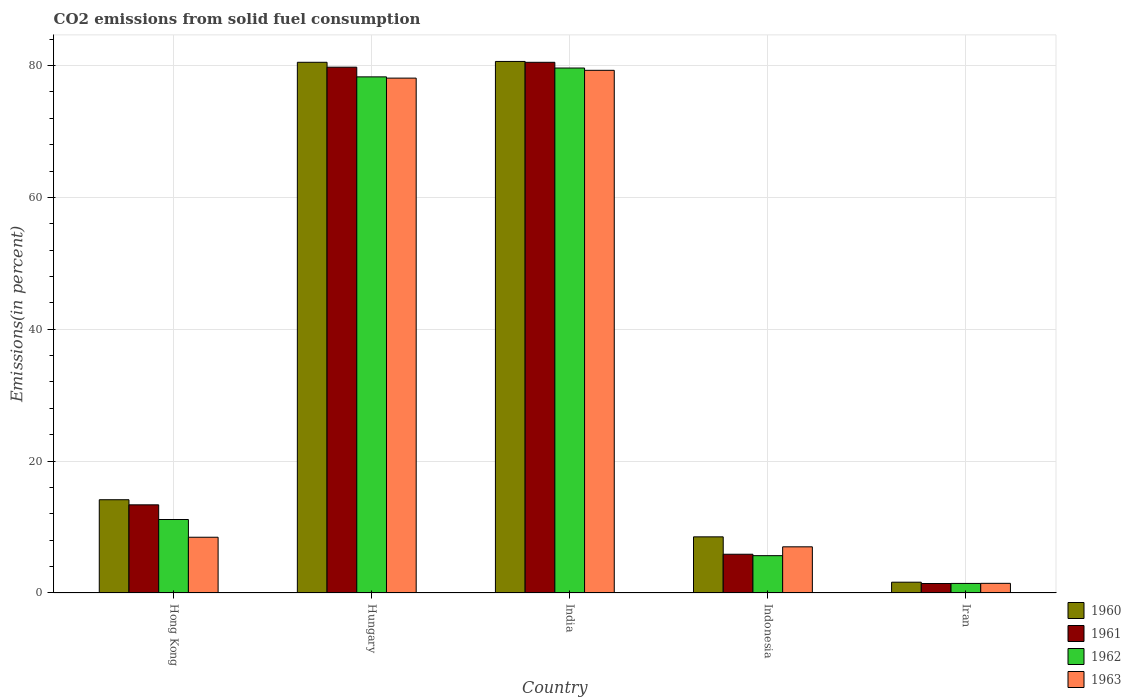How many different coloured bars are there?
Your answer should be very brief. 4. How many groups of bars are there?
Keep it short and to the point. 5. Are the number of bars per tick equal to the number of legend labels?
Offer a terse response. Yes. Are the number of bars on each tick of the X-axis equal?
Your response must be concise. Yes. How many bars are there on the 3rd tick from the left?
Keep it short and to the point. 4. How many bars are there on the 3rd tick from the right?
Provide a succinct answer. 4. What is the label of the 1st group of bars from the left?
Your response must be concise. Hong Kong. What is the total CO2 emitted in 1963 in Hong Kong?
Give a very brief answer. 8.46. Across all countries, what is the maximum total CO2 emitted in 1960?
Offer a very short reply. 80.62. Across all countries, what is the minimum total CO2 emitted in 1962?
Provide a succinct answer. 1.45. In which country was the total CO2 emitted in 1961 maximum?
Your answer should be compact. India. In which country was the total CO2 emitted in 1962 minimum?
Your answer should be very brief. Iran. What is the total total CO2 emitted in 1962 in the graph?
Keep it short and to the point. 176.15. What is the difference between the total CO2 emitted in 1961 in Hong Kong and that in India?
Offer a very short reply. -67.12. What is the difference between the total CO2 emitted in 1960 in Indonesia and the total CO2 emitted in 1963 in Hong Kong?
Offer a terse response. 0.06. What is the average total CO2 emitted in 1961 per country?
Offer a very short reply. 36.18. What is the difference between the total CO2 emitted of/in 1963 and total CO2 emitted of/in 1960 in Indonesia?
Your answer should be compact. -1.51. What is the ratio of the total CO2 emitted in 1960 in Hungary to that in India?
Give a very brief answer. 1. Is the total CO2 emitted in 1962 in Hong Kong less than that in Indonesia?
Your response must be concise. No. What is the difference between the highest and the second highest total CO2 emitted in 1963?
Make the answer very short. -69.63. What is the difference between the highest and the lowest total CO2 emitted in 1962?
Your answer should be very brief. 78.17. In how many countries, is the total CO2 emitted in 1963 greater than the average total CO2 emitted in 1963 taken over all countries?
Offer a terse response. 2. Is the sum of the total CO2 emitted in 1963 in Hungary and Iran greater than the maximum total CO2 emitted in 1961 across all countries?
Offer a terse response. No. Is it the case that in every country, the sum of the total CO2 emitted in 1960 and total CO2 emitted in 1962 is greater than the sum of total CO2 emitted in 1963 and total CO2 emitted in 1961?
Provide a succinct answer. No. What does the 2nd bar from the left in Indonesia represents?
Offer a very short reply. 1961. What does the 1st bar from the right in Iran represents?
Give a very brief answer. 1963. Are the values on the major ticks of Y-axis written in scientific E-notation?
Ensure brevity in your answer.  No. How many legend labels are there?
Offer a terse response. 4. How are the legend labels stacked?
Offer a terse response. Vertical. What is the title of the graph?
Your answer should be very brief. CO2 emissions from solid fuel consumption. Does "2009" appear as one of the legend labels in the graph?
Provide a succinct answer. No. What is the label or title of the Y-axis?
Offer a very short reply. Emissions(in percent). What is the Emissions(in percent) of 1960 in Hong Kong?
Give a very brief answer. 14.14. What is the Emissions(in percent) in 1961 in Hong Kong?
Offer a terse response. 13.37. What is the Emissions(in percent) of 1962 in Hong Kong?
Make the answer very short. 11.14. What is the Emissions(in percent) in 1963 in Hong Kong?
Your answer should be very brief. 8.46. What is the Emissions(in percent) of 1960 in Hungary?
Offer a terse response. 80.49. What is the Emissions(in percent) of 1961 in Hungary?
Ensure brevity in your answer.  79.75. What is the Emissions(in percent) of 1962 in Hungary?
Make the answer very short. 78.28. What is the Emissions(in percent) in 1963 in Hungary?
Give a very brief answer. 78.09. What is the Emissions(in percent) in 1960 in India?
Give a very brief answer. 80.62. What is the Emissions(in percent) of 1961 in India?
Give a very brief answer. 80.49. What is the Emissions(in percent) in 1962 in India?
Your answer should be compact. 79.62. What is the Emissions(in percent) of 1963 in India?
Offer a terse response. 79.27. What is the Emissions(in percent) in 1960 in Indonesia?
Your response must be concise. 8.51. What is the Emissions(in percent) in 1961 in Indonesia?
Your response must be concise. 5.88. What is the Emissions(in percent) in 1962 in Indonesia?
Provide a succinct answer. 5.66. What is the Emissions(in percent) of 1963 in Indonesia?
Your answer should be compact. 7. What is the Emissions(in percent) in 1960 in Iran?
Your answer should be very brief. 1.64. What is the Emissions(in percent) in 1961 in Iran?
Your response must be concise. 1.44. What is the Emissions(in percent) of 1962 in Iran?
Your response must be concise. 1.45. What is the Emissions(in percent) in 1963 in Iran?
Your answer should be very brief. 1.46. Across all countries, what is the maximum Emissions(in percent) in 1960?
Offer a very short reply. 80.62. Across all countries, what is the maximum Emissions(in percent) of 1961?
Provide a short and direct response. 80.49. Across all countries, what is the maximum Emissions(in percent) in 1962?
Your answer should be compact. 79.62. Across all countries, what is the maximum Emissions(in percent) of 1963?
Offer a terse response. 79.27. Across all countries, what is the minimum Emissions(in percent) in 1960?
Your answer should be very brief. 1.64. Across all countries, what is the minimum Emissions(in percent) in 1961?
Give a very brief answer. 1.44. Across all countries, what is the minimum Emissions(in percent) in 1962?
Make the answer very short. 1.45. Across all countries, what is the minimum Emissions(in percent) of 1963?
Give a very brief answer. 1.46. What is the total Emissions(in percent) in 1960 in the graph?
Your response must be concise. 185.4. What is the total Emissions(in percent) in 1961 in the graph?
Your response must be concise. 180.91. What is the total Emissions(in percent) of 1962 in the graph?
Your answer should be compact. 176.15. What is the total Emissions(in percent) in 1963 in the graph?
Offer a very short reply. 174.28. What is the difference between the Emissions(in percent) in 1960 in Hong Kong and that in Hungary?
Ensure brevity in your answer.  -66.35. What is the difference between the Emissions(in percent) of 1961 in Hong Kong and that in Hungary?
Your answer should be compact. -66.38. What is the difference between the Emissions(in percent) of 1962 in Hong Kong and that in Hungary?
Your response must be concise. -67.13. What is the difference between the Emissions(in percent) of 1963 in Hong Kong and that in Hungary?
Your response must be concise. -69.63. What is the difference between the Emissions(in percent) of 1960 in Hong Kong and that in India?
Ensure brevity in your answer.  -66.47. What is the difference between the Emissions(in percent) of 1961 in Hong Kong and that in India?
Your answer should be very brief. -67.12. What is the difference between the Emissions(in percent) of 1962 in Hong Kong and that in India?
Offer a very short reply. -68.47. What is the difference between the Emissions(in percent) in 1963 in Hong Kong and that in India?
Your answer should be compact. -70.82. What is the difference between the Emissions(in percent) in 1960 in Hong Kong and that in Indonesia?
Give a very brief answer. 5.63. What is the difference between the Emissions(in percent) of 1961 in Hong Kong and that in Indonesia?
Provide a short and direct response. 7.49. What is the difference between the Emissions(in percent) of 1962 in Hong Kong and that in Indonesia?
Provide a succinct answer. 5.48. What is the difference between the Emissions(in percent) in 1963 in Hong Kong and that in Indonesia?
Your answer should be compact. 1.45. What is the difference between the Emissions(in percent) in 1960 in Hong Kong and that in Iran?
Offer a terse response. 12.51. What is the difference between the Emissions(in percent) in 1961 in Hong Kong and that in Iran?
Keep it short and to the point. 11.93. What is the difference between the Emissions(in percent) of 1962 in Hong Kong and that in Iran?
Keep it short and to the point. 9.7. What is the difference between the Emissions(in percent) of 1963 in Hong Kong and that in Iran?
Provide a succinct answer. 6.99. What is the difference between the Emissions(in percent) in 1960 in Hungary and that in India?
Ensure brevity in your answer.  -0.13. What is the difference between the Emissions(in percent) in 1961 in Hungary and that in India?
Your answer should be very brief. -0.74. What is the difference between the Emissions(in percent) of 1962 in Hungary and that in India?
Make the answer very short. -1.34. What is the difference between the Emissions(in percent) of 1963 in Hungary and that in India?
Keep it short and to the point. -1.18. What is the difference between the Emissions(in percent) of 1960 in Hungary and that in Indonesia?
Ensure brevity in your answer.  71.98. What is the difference between the Emissions(in percent) of 1961 in Hungary and that in Indonesia?
Your answer should be very brief. 73.87. What is the difference between the Emissions(in percent) in 1962 in Hungary and that in Indonesia?
Provide a succinct answer. 72.62. What is the difference between the Emissions(in percent) in 1963 in Hungary and that in Indonesia?
Your answer should be very brief. 71.09. What is the difference between the Emissions(in percent) of 1960 in Hungary and that in Iran?
Make the answer very short. 78.85. What is the difference between the Emissions(in percent) of 1961 in Hungary and that in Iran?
Your answer should be compact. 78.31. What is the difference between the Emissions(in percent) of 1962 in Hungary and that in Iran?
Make the answer very short. 76.83. What is the difference between the Emissions(in percent) in 1963 in Hungary and that in Iran?
Your response must be concise. 76.62. What is the difference between the Emissions(in percent) of 1960 in India and that in Indonesia?
Keep it short and to the point. 72.1. What is the difference between the Emissions(in percent) in 1961 in India and that in Indonesia?
Provide a short and direct response. 74.61. What is the difference between the Emissions(in percent) of 1962 in India and that in Indonesia?
Offer a terse response. 73.96. What is the difference between the Emissions(in percent) of 1963 in India and that in Indonesia?
Offer a terse response. 72.27. What is the difference between the Emissions(in percent) in 1960 in India and that in Iran?
Your answer should be compact. 78.98. What is the difference between the Emissions(in percent) of 1961 in India and that in Iran?
Offer a terse response. 79.05. What is the difference between the Emissions(in percent) in 1962 in India and that in Iran?
Provide a succinct answer. 78.17. What is the difference between the Emissions(in percent) in 1963 in India and that in Iran?
Provide a succinct answer. 77.81. What is the difference between the Emissions(in percent) in 1960 in Indonesia and that in Iran?
Your answer should be very brief. 6.88. What is the difference between the Emissions(in percent) in 1961 in Indonesia and that in Iran?
Provide a short and direct response. 4.44. What is the difference between the Emissions(in percent) in 1962 in Indonesia and that in Iran?
Offer a very short reply. 4.21. What is the difference between the Emissions(in percent) in 1963 in Indonesia and that in Iran?
Offer a terse response. 5.54. What is the difference between the Emissions(in percent) of 1960 in Hong Kong and the Emissions(in percent) of 1961 in Hungary?
Your response must be concise. -65.6. What is the difference between the Emissions(in percent) of 1960 in Hong Kong and the Emissions(in percent) of 1962 in Hungary?
Keep it short and to the point. -64.13. What is the difference between the Emissions(in percent) in 1960 in Hong Kong and the Emissions(in percent) in 1963 in Hungary?
Provide a short and direct response. -63.94. What is the difference between the Emissions(in percent) of 1961 in Hong Kong and the Emissions(in percent) of 1962 in Hungary?
Your response must be concise. -64.91. What is the difference between the Emissions(in percent) of 1961 in Hong Kong and the Emissions(in percent) of 1963 in Hungary?
Offer a very short reply. -64.72. What is the difference between the Emissions(in percent) of 1962 in Hong Kong and the Emissions(in percent) of 1963 in Hungary?
Provide a short and direct response. -66.94. What is the difference between the Emissions(in percent) in 1960 in Hong Kong and the Emissions(in percent) in 1961 in India?
Your answer should be very brief. -66.34. What is the difference between the Emissions(in percent) in 1960 in Hong Kong and the Emissions(in percent) in 1962 in India?
Make the answer very short. -65.47. What is the difference between the Emissions(in percent) in 1960 in Hong Kong and the Emissions(in percent) in 1963 in India?
Keep it short and to the point. -65.13. What is the difference between the Emissions(in percent) in 1961 in Hong Kong and the Emissions(in percent) in 1962 in India?
Provide a succinct answer. -66.25. What is the difference between the Emissions(in percent) of 1961 in Hong Kong and the Emissions(in percent) of 1963 in India?
Make the answer very short. -65.9. What is the difference between the Emissions(in percent) of 1962 in Hong Kong and the Emissions(in percent) of 1963 in India?
Provide a short and direct response. -68.13. What is the difference between the Emissions(in percent) of 1960 in Hong Kong and the Emissions(in percent) of 1961 in Indonesia?
Provide a succinct answer. 8.27. What is the difference between the Emissions(in percent) of 1960 in Hong Kong and the Emissions(in percent) of 1962 in Indonesia?
Give a very brief answer. 8.48. What is the difference between the Emissions(in percent) of 1960 in Hong Kong and the Emissions(in percent) of 1963 in Indonesia?
Ensure brevity in your answer.  7.14. What is the difference between the Emissions(in percent) in 1961 in Hong Kong and the Emissions(in percent) in 1962 in Indonesia?
Give a very brief answer. 7.71. What is the difference between the Emissions(in percent) in 1961 in Hong Kong and the Emissions(in percent) in 1963 in Indonesia?
Offer a terse response. 6.37. What is the difference between the Emissions(in percent) of 1962 in Hong Kong and the Emissions(in percent) of 1963 in Indonesia?
Provide a succinct answer. 4.14. What is the difference between the Emissions(in percent) of 1960 in Hong Kong and the Emissions(in percent) of 1961 in Iran?
Your response must be concise. 12.71. What is the difference between the Emissions(in percent) in 1960 in Hong Kong and the Emissions(in percent) in 1962 in Iran?
Keep it short and to the point. 12.7. What is the difference between the Emissions(in percent) in 1960 in Hong Kong and the Emissions(in percent) in 1963 in Iran?
Offer a very short reply. 12.68. What is the difference between the Emissions(in percent) in 1961 in Hong Kong and the Emissions(in percent) in 1962 in Iran?
Make the answer very short. 11.92. What is the difference between the Emissions(in percent) of 1961 in Hong Kong and the Emissions(in percent) of 1963 in Iran?
Your response must be concise. 11.91. What is the difference between the Emissions(in percent) in 1962 in Hong Kong and the Emissions(in percent) in 1963 in Iran?
Your response must be concise. 9.68. What is the difference between the Emissions(in percent) in 1960 in Hungary and the Emissions(in percent) in 1961 in India?
Ensure brevity in your answer.  0. What is the difference between the Emissions(in percent) of 1960 in Hungary and the Emissions(in percent) of 1962 in India?
Your answer should be compact. 0.87. What is the difference between the Emissions(in percent) in 1960 in Hungary and the Emissions(in percent) in 1963 in India?
Offer a very short reply. 1.22. What is the difference between the Emissions(in percent) in 1961 in Hungary and the Emissions(in percent) in 1962 in India?
Your answer should be compact. 0.13. What is the difference between the Emissions(in percent) in 1961 in Hungary and the Emissions(in percent) in 1963 in India?
Make the answer very short. 0.48. What is the difference between the Emissions(in percent) in 1962 in Hungary and the Emissions(in percent) in 1963 in India?
Give a very brief answer. -0.99. What is the difference between the Emissions(in percent) of 1960 in Hungary and the Emissions(in percent) of 1961 in Indonesia?
Provide a succinct answer. 74.61. What is the difference between the Emissions(in percent) in 1960 in Hungary and the Emissions(in percent) in 1962 in Indonesia?
Provide a succinct answer. 74.83. What is the difference between the Emissions(in percent) of 1960 in Hungary and the Emissions(in percent) of 1963 in Indonesia?
Keep it short and to the point. 73.49. What is the difference between the Emissions(in percent) in 1961 in Hungary and the Emissions(in percent) in 1962 in Indonesia?
Give a very brief answer. 74.09. What is the difference between the Emissions(in percent) of 1961 in Hungary and the Emissions(in percent) of 1963 in Indonesia?
Ensure brevity in your answer.  72.75. What is the difference between the Emissions(in percent) of 1962 in Hungary and the Emissions(in percent) of 1963 in Indonesia?
Keep it short and to the point. 71.28. What is the difference between the Emissions(in percent) of 1960 in Hungary and the Emissions(in percent) of 1961 in Iran?
Your answer should be very brief. 79.05. What is the difference between the Emissions(in percent) of 1960 in Hungary and the Emissions(in percent) of 1962 in Iran?
Your response must be concise. 79.04. What is the difference between the Emissions(in percent) of 1960 in Hungary and the Emissions(in percent) of 1963 in Iran?
Make the answer very short. 79.03. What is the difference between the Emissions(in percent) in 1961 in Hungary and the Emissions(in percent) in 1962 in Iran?
Provide a short and direct response. 78.3. What is the difference between the Emissions(in percent) of 1961 in Hungary and the Emissions(in percent) of 1963 in Iran?
Offer a terse response. 78.28. What is the difference between the Emissions(in percent) of 1962 in Hungary and the Emissions(in percent) of 1963 in Iran?
Offer a very short reply. 76.81. What is the difference between the Emissions(in percent) of 1960 in India and the Emissions(in percent) of 1961 in Indonesia?
Your answer should be compact. 74.74. What is the difference between the Emissions(in percent) of 1960 in India and the Emissions(in percent) of 1962 in Indonesia?
Offer a terse response. 74.96. What is the difference between the Emissions(in percent) in 1960 in India and the Emissions(in percent) in 1963 in Indonesia?
Offer a very short reply. 73.61. What is the difference between the Emissions(in percent) of 1961 in India and the Emissions(in percent) of 1962 in Indonesia?
Provide a short and direct response. 74.83. What is the difference between the Emissions(in percent) in 1961 in India and the Emissions(in percent) in 1963 in Indonesia?
Your response must be concise. 73.49. What is the difference between the Emissions(in percent) in 1962 in India and the Emissions(in percent) in 1963 in Indonesia?
Offer a terse response. 72.62. What is the difference between the Emissions(in percent) in 1960 in India and the Emissions(in percent) in 1961 in Iran?
Provide a short and direct response. 79.18. What is the difference between the Emissions(in percent) of 1960 in India and the Emissions(in percent) of 1962 in Iran?
Your response must be concise. 79.17. What is the difference between the Emissions(in percent) of 1960 in India and the Emissions(in percent) of 1963 in Iran?
Keep it short and to the point. 79.15. What is the difference between the Emissions(in percent) in 1961 in India and the Emissions(in percent) in 1962 in Iran?
Offer a very short reply. 79.04. What is the difference between the Emissions(in percent) in 1961 in India and the Emissions(in percent) in 1963 in Iran?
Give a very brief answer. 79.02. What is the difference between the Emissions(in percent) in 1962 in India and the Emissions(in percent) in 1963 in Iran?
Offer a very short reply. 78.16. What is the difference between the Emissions(in percent) in 1960 in Indonesia and the Emissions(in percent) in 1961 in Iran?
Make the answer very short. 7.08. What is the difference between the Emissions(in percent) in 1960 in Indonesia and the Emissions(in percent) in 1962 in Iran?
Provide a short and direct response. 7.07. What is the difference between the Emissions(in percent) of 1960 in Indonesia and the Emissions(in percent) of 1963 in Iran?
Your answer should be compact. 7.05. What is the difference between the Emissions(in percent) in 1961 in Indonesia and the Emissions(in percent) in 1962 in Iran?
Give a very brief answer. 4.43. What is the difference between the Emissions(in percent) of 1961 in Indonesia and the Emissions(in percent) of 1963 in Iran?
Give a very brief answer. 4.41. What is the difference between the Emissions(in percent) of 1962 in Indonesia and the Emissions(in percent) of 1963 in Iran?
Your response must be concise. 4.2. What is the average Emissions(in percent) of 1960 per country?
Ensure brevity in your answer.  37.08. What is the average Emissions(in percent) in 1961 per country?
Make the answer very short. 36.18. What is the average Emissions(in percent) of 1962 per country?
Provide a short and direct response. 35.23. What is the average Emissions(in percent) in 1963 per country?
Provide a succinct answer. 34.86. What is the difference between the Emissions(in percent) of 1960 and Emissions(in percent) of 1961 in Hong Kong?
Keep it short and to the point. 0.77. What is the difference between the Emissions(in percent) in 1960 and Emissions(in percent) in 1962 in Hong Kong?
Give a very brief answer. 3. What is the difference between the Emissions(in percent) in 1960 and Emissions(in percent) in 1963 in Hong Kong?
Ensure brevity in your answer.  5.69. What is the difference between the Emissions(in percent) of 1961 and Emissions(in percent) of 1962 in Hong Kong?
Your answer should be compact. 2.23. What is the difference between the Emissions(in percent) of 1961 and Emissions(in percent) of 1963 in Hong Kong?
Your response must be concise. 4.91. What is the difference between the Emissions(in percent) of 1962 and Emissions(in percent) of 1963 in Hong Kong?
Give a very brief answer. 2.69. What is the difference between the Emissions(in percent) in 1960 and Emissions(in percent) in 1961 in Hungary?
Offer a very short reply. 0.74. What is the difference between the Emissions(in percent) of 1960 and Emissions(in percent) of 1962 in Hungary?
Offer a terse response. 2.21. What is the difference between the Emissions(in percent) of 1960 and Emissions(in percent) of 1963 in Hungary?
Give a very brief answer. 2.4. What is the difference between the Emissions(in percent) in 1961 and Emissions(in percent) in 1962 in Hungary?
Your response must be concise. 1.47. What is the difference between the Emissions(in percent) of 1961 and Emissions(in percent) of 1963 in Hungary?
Ensure brevity in your answer.  1.66. What is the difference between the Emissions(in percent) of 1962 and Emissions(in percent) of 1963 in Hungary?
Keep it short and to the point. 0.19. What is the difference between the Emissions(in percent) in 1960 and Emissions(in percent) in 1961 in India?
Your answer should be very brief. 0.13. What is the difference between the Emissions(in percent) of 1960 and Emissions(in percent) of 1963 in India?
Keep it short and to the point. 1.34. What is the difference between the Emissions(in percent) in 1961 and Emissions(in percent) in 1962 in India?
Offer a terse response. 0.87. What is the difference between the Emissions(in percent) in 1961 and Emissions(in percent) in 1963 in India?
Provide a short and direct response. 1.22. What is the difference between the Emissions(in percent) of 1962 and Emissions(in percent) of 1963 in India?
Your response must be concise. 0.35. What is the difference between the Emissions(in percent) of 1960 and Emissions(in percent) of 1961 in Indonesia?
Your response must be concise. 2.64. What is the difference between the Emissions(in percent) in 1960 and Emissions(in percent) in 1962 in Indonesia?
Ensure brevity in your answer.  2.85. What is the difference between the Emissions(in percent) in 1960 and Emissions(in percent) in 1963 in Indonesia?
Make the answer very short. 1.51. What is the difference between the Emissions(in percent) in 1961 and Emissions(in percent) in 1962 in Indonesia?
Keep it short and to the point. 0.21. What is the difference between the Emissions(in percent) of 1961 and Emissions(in percent) of 1963 in Indonesia?
Make the answer very short. -1.13. What is the difference between the Emissions(in percent) in 1962 and Emissions(in percent) in 1963 in Indonesia?
Ensure brevity in your answer.  -1.34. What is the difference between the Emissions(in percent) in 1960 and Emissions(in percent) in 1961 in Iran?
Offer a very short reply. 0.2. What is the difference between the Emissions(in percent) in 1960 and Emissions(in percent) in 1962 in Iran?
Make the answer very short. 0.19. What is the difference between the Emissions(in percent) in 1960 and Emissions(in percent) in 1963 in Iran?
Offer a very short reply. 0.17. What is the difference between the Emissions(in percent) of 1961 and Emissions(in percent) of 1962 in Iran?
Offer a terse response. -0.01. What is the difference between the Emissions(in percent) in 1961 and Emissions(in percent) in 1963 in Iran?
Provide a succinct answer. -0.03. What is the difference between the Emissions(in percent) of 1962 and Emissions(in percent) of 1963 in Iran?
Ensure brevity in your answer.  -0.01. What is the ratio of the Emissions(in percent) in 1960 in Hong Kong to that in Hungary?
Your answer should be very brief. 0.18. What is the ratio of the Emissions(in percent) in 1961 in Hong Kong to that in Hungary?
Your answer should be very brief. 0.17. What is the ratio of the Emissions(in percent) of 1962 in Hong Kong to that in Hungary?
Provide a short and direct response. 0.14. What is the ratio of the Emissions(in percent) of 1963 in Hong Kong to that in Hungary?
Provide a succinct answer. 0.11. What is the ratio of the Emissions(in percent) of 1960 in Hong Kong to that in India?
Your response must be concise. 0.18. What is the ratio of the Emissions(in percent) of 1961 in Hong Kong to that in India?
Ensure brevity in your answer.  0.17. What is the ratio of the Emissions(in percent) in 1962 in Hong Kong to that in India?
Provide a short and direct response. 0.14. What is the ratio of the Emissions(in percent) of 1963 in Hong Kong to that in India?
Make the answer very short. 0.11. What is the ratio of the Emissions(in percent) in 1960 in Hong Kong to that in Indonesia?
Provide a succinct answer. 1.66. What is the ratio of the Emissions(in percent) in 1961 in Hong Kong to that in Indonesia?
Provide a short and direct response. 2.28. What is the ratio of the Emissions(in percent) in 1962 in Hong Kong to that in Indonesia?
Keep it short and to the point. 1.97. What is the ratio of the Emissions(in percent) in 1963 in Hong Kong to that in Indonesia?
Offer a terse response. 1.21. What is the ratio of the Emissions(in percent) in 1960 in Hong Kong to that in Iran?
Make the answer very short. 8.64. What is the ratio of the Emissions(in percent) in 1961 in Hong Kong to that in Iran?
Your answer should be compact. 9.32. What is the ratio of the Emissions(in percent) of 1962 in Hong Kong to that in Iran?
Offer a terse response. 7.69. What is the ratio of the Emissions(in percent) in 1963 in Hong Kong to that in Iran?
Make the answer very short. 5.78. What is the ratio of the Emissions(in percent) of 1960 in Hungary to that in India?
Keep it short and to the point. 1. What is the ratio of the Emissions(in percent) of 1962 in Hungary to that in India?
Offer a terse response. 0.98. What is the ratio of the Emissions(in percent) in 1963 in Hungary to that in India?
Keep it short and to the point. 0.99. What is the ratio of the Emissions(in percent) of 1960 in Hungary to that in Indonesia?
Give a very brief answer. 9.45. What is the ratio of the Emissions(in percent) in 1961 in Hungary to that in Indonesia?
Keep it short and to the point. 13.57. What is the ratio of the Emissions(in percent) in 1962 in Hungary to that in Indonesia?
Keep it short and to the point. 13.83. What is the ratio of the Emissions(in percent) in 1963 in Hungary to that in Indonesia?
Your response must be concise. 11.15. What is the ratio of the Emissions(in percent) in 1960 in Hungary to that in Iran?
Provide a short and direct response. 49.15. What is the ratio of the Emissions(in percent) in 1961 in Hungary to that in Iran?
Keep it short and to the point. 55.57. What is the ratio of the Emissions(in percent) in 1962 in Hungary to that in Iran?
Keep it short and to the point. 54.03. What is the ratio of the Emissions(in percent) in 1963 in Hungary to that in Iran?
Make the answer very short. 53.36. What is the ratio of the Emissions(in percent) of 1960 in India to that in Indonesia?
Make the answer very short. 9.47. What is the ratio of the Emissions(in percent) in 1961 in India to that in Indonesia?
Your response must be concise. 13.7. What is the ratio of the Emissions(in percent) in 1962 in India to that in Indonesia?
Make the answer very short. 14.06. What is the ratio of the Emissions(in percent) of 1963 in India to that in Indonesia?
Offer a terse response. 11.32. What is the ratio of the Emissions(in percent) in 1960 in India to that in Iran?
Offer a terse response. 49.22. What is the ratio of the Emissions(in percent) of 1961 in India to that in Iran?
Keep it short and to the point. 56.09. What is the ratio of the Emissions(in percent) in 1962 in India to that in Iran?
Your answer should be compact. 54.96. What is the ratio of the Emissions(in percent) of 1963 in India to that in Iran?
Keep it short and to the point. 54.16. What is the ratio of the Emissions(in percent) of 1960 in Indonesia to that in Iran?
Provide a succinct answer. 5.2. What is the ratio of the Emissions(in percent) of 1961 in Indonesia to that in Iran?
Give a very brief answer. 4.09. What is the ratio of the Emissions(in percent) of 1962 in Indonesia to that in Iran?
Make the answer very short. 3.91. What is the ratio of the Emissions(in percent) in 1963 in Indonesia to that in Iran?
Your response must be concise. 4.78. What is the difference between the highest and the second highest Emissions(in percent) in 1960?
Give a very brief answer. 0.13. What is the difference between the highest and the second highest Emissions(in percent) in 1961?
Provide a short and direct response. 0.74. What is the difference between the highest and the second highest Emissions(in percent) of 1962?
Provide a succinct answer. 1.34. What is the difference between the highest and the second highest Emissions(in percent) in 1963?
Give a very brief answer. 1.18. What is the difference between the highest and the lowest Emissions(in percent) in 1960?
Give a very brief answer. 78.98. What is the difference between the highest and the lowest Emissions(in percent) in 1961?
Provide a short and direct response. 79.05. What is the difference between the highest and the lowest Emissions(in percent) in 1962?
Provide a succinct answer. 78.17. What is the difference between the highest and the lowest Emissions(in percent) in 1963?
Provide a succinct answer. 77.81. 